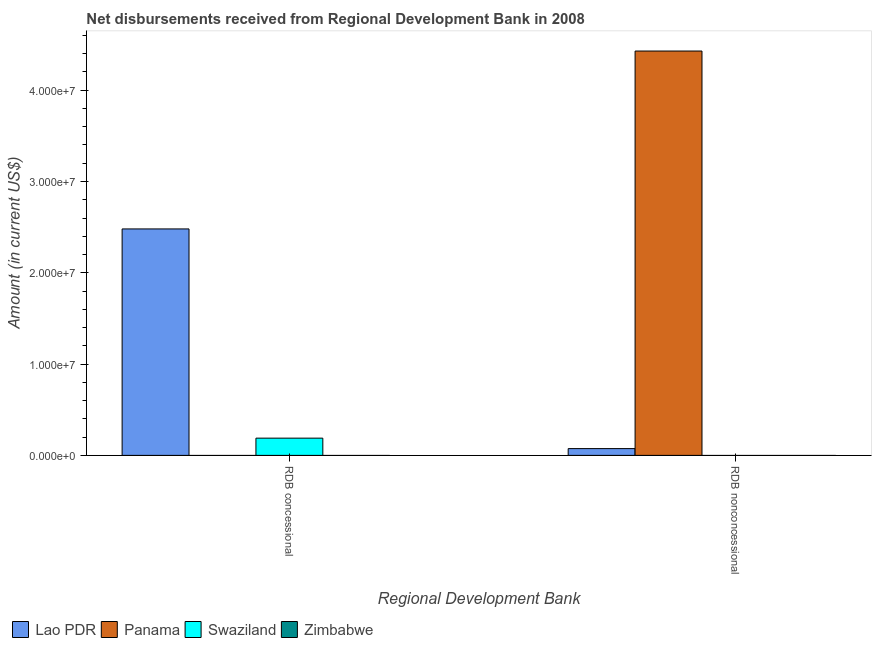Are the number of bars on each tick of the X-axis equal?
Provide a succinct answer. Yes. What is the label of the 2nd group of bars from the left?
Offer a terse response. RDB nonconcessional. What is the net concessional disbursements from rdb in Panama?
Offer a very short reply. 0. Across all countries, what is the maximum net concessional disbursements from rdb?
Ensure brevity in your answer.  2.48e+07. In which country was the net concessional disbursements from rdb maximum?
Ensure brevity in your answer.  Lao PDR. What is the total net concessional disbursements from rdb in the graph?
Keep it short and to the point. 2.67e+07. What is the difference between the net non concessional disbursements from rdb in Panama and that in Lao PDR?
Offer a terse response. 4.35e+07. What is the difference between the net concessional disbursements from rdb in Swaziland and the net non concessional disbursements from rdb in Lao PDR?
Offer a very short reply. 1.14e+06. What is the average net non concessional disbursements from rdb per country?
Your answer should be very brief. 1.13e+07. What is the difference between the net concessional disbursements from rdb and net non concessional disbursements from rdb in Lao PDR?
Provide a short and direct response. 2.41e+07. What is the ratio of the net concessional disbursements from rdb in Lao PDR to that in Swaziland?
Provide a succinct answer. 13.14. In how many countries, is the net non concessional disbursements from rdb greater than the average net non concessional disbursements from rdb taken over all countries?
Keep it short and to the point. 1. How many bars are there?
Make the answer very short. 4. Are all the bars in the graph horizontal?
Provide a succinct answer. No. Does the graph contain any zero values?
Keep it short and to the point. Yes. How many legend labels are there?
Provide a short and direct response. 4. How are the legend labels stacked?
Offer a terse response. Horizontal. What is the title of the graph?
Offer a very short reply. Net disbursements received from Regional Development Bank in 2008. Does "Denmark" appear as one of the legend labels in the graph?
Make the answer very short. No. What is the label or title of the X-axis?
Give a very brief answer. Regional Development Bank. What is the label or title of the Y-axis?
Offer a very short reply. Amount (in current US$). What is the Amount (in current US$) in Lao PDR in RDB concessional?
Offer a very short reply. 2.48e+07. What is the Amount (in current US$) of Panama in RDB concessional?
Give a very brief answer. 0. What is the Amount (in current US$) of Swaziland in RDB concessional?
Make the answer very short. 1.89e+06. What is the Amount (in current US$) in Zimbabwe in RDB concessional?
Your answer should be very brief. 0. What is the Amount (in current US$) of Lao PDR in RDB nonconcessional?
Keep it short and to the point. 7.44e+05. What is the Amount (in current US$) in Panama in RDB nonconcessional?
Your answer should be very brief. 4.43e+07. What is the Amount (in current US$) in Zimbabwe in RDB nonconcessional?
Offer a very short reply. 0. Across all Regional Development Bank, what is the maximum Amount (in current US$) in Lao PDR?
Your response must be concise. 2.48e+07. Across all Regional Development Bank, what is the maximum Amount (in current US$) in Panama?
Provide a short and direct response. 4.43e+07. Across all Regional Development Bank, what is the maximum Amount (in current US$) of Swaziland?
Your response must be concise. 1.89e+06. Across all Regional Development Bank, what is the minimum Amount (in current US$) in Lao PDR?
Offer a very short reply. 7.44e+05. Across all Regional Development Bank, what is the minimum Amount (in current US$) of Panama?
Ensure brevity in your answer.  0. Across all Regional Development Bank, what is the minimum Amount (in current US$) of Swaziland?
Ensure brevity in your answer.  0. What is the total Amount (in current US$) in Lao PDR in the graph?
Make the answer very short. 2.55e+07. What is the total Amount (in current US$) in Panama in the graph?
Your response must be concise. 4.43e+07. What is the total Amount (in current US$) in Swaziland in the graph?
Offer a very short reply. 1.89e+06. What is the total Amount (in current US$) of Zimbabwe in the graph?
Keep it short and to the point. 0. What is the difference between the Amount (in current US$) in Lao PDR in RDB concessional and that in RDB nonconcessional?
Keep it short and to the point. 2.41e+07. What is the difference between the Amount (in current US$) of Lao PDR in RDB concessional and the Amount (in current US$) of Panama in RDB nonconcessional?
Your response must be concise. -1.95e+07. What is the average Amount (in current US$) in Lao PDR per Regional Development Bank?
Keep it short and to the point. 1.28e+07. What is the average Amount (in current US$) of Panama per Regional Development Bank?
Give a very brief answer. 2.21e+07. What is the average Amount (in current US$) in Swaziland per Regional Development Bank?
Offer a very short reply. 9.44e+05. What is the average Amount (in current US$) in Zimbabwe per Regional Development Bank?
Provide a succinct answer. 0. What is the difference between the Amount (in current US$) in Lao PDR and Amount (in current US$) in Swaziland in RDB concessional?
Provide a short and direct response. 2.29e+07. What is the difference between the Amount (in current US$) in Lao PDR and Amount (in current US$) in Panama in RDB nonconcessional?
Make the answer very short. -4.35e+07. What is the ratio of the Amount (in current US$) in Lao PDR in RDB concessional to that in RDB nonconcessional?
Your response must be concise. 33.34. What is the difference between the highest and the second highest Amount (in current US$) of Lao PDR?
Ensure brevity in your answer.  2.41e+07. What is the difference between the highest and the lowest Amount (in current US$) of Lao PDR?
Keep it short and to the point. 2.41e+07. What is the difference between the highest and the lowest Amount (in current US$) in Panama?
Offer a terse response. 4.43e+07. What is the difference between the highest and the lowest Amount (in current US$) in Swaziland?
Ensure brevity in your answer.  1.89e+06. 